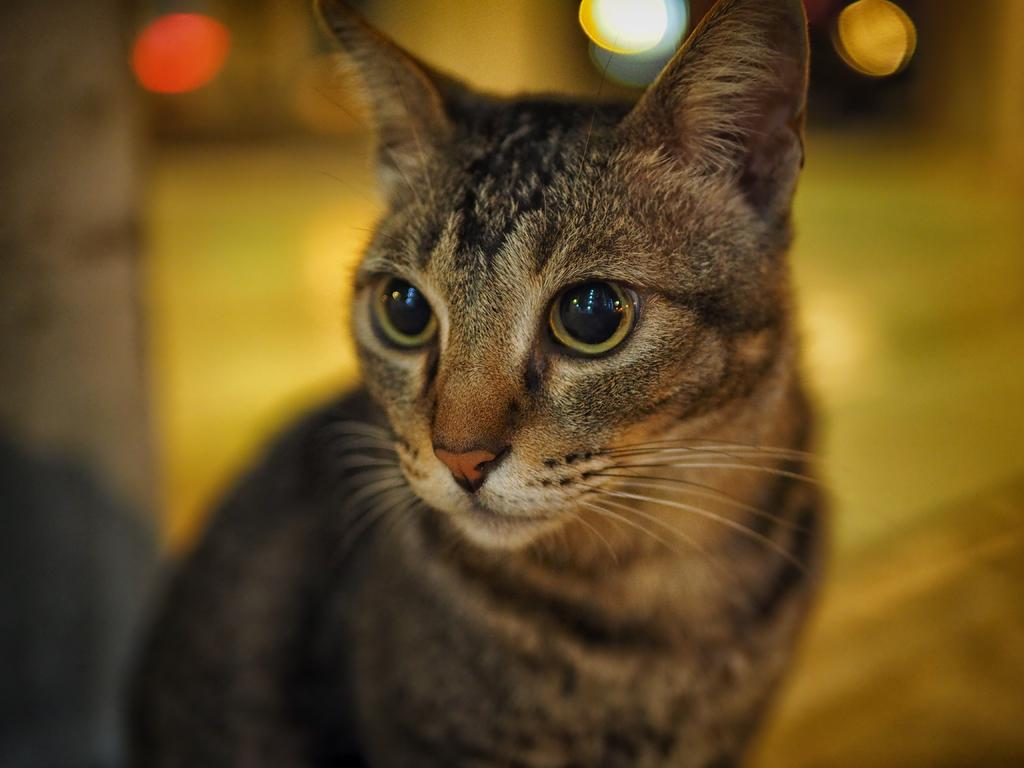What type of animal is in the image? There is a cat in the image. What color is the cat? The cat is brown in color. What can be seen in the background of the image? There are lights in the background of the image. How would you describe the background of the image? The background of the image is blurred. What type of mark can be seen on the quilt in the image? There is no quilt present in the image, and therefore no marks can be observed on it. How many sheep are visible in the image? There are no sheep present in the image. 